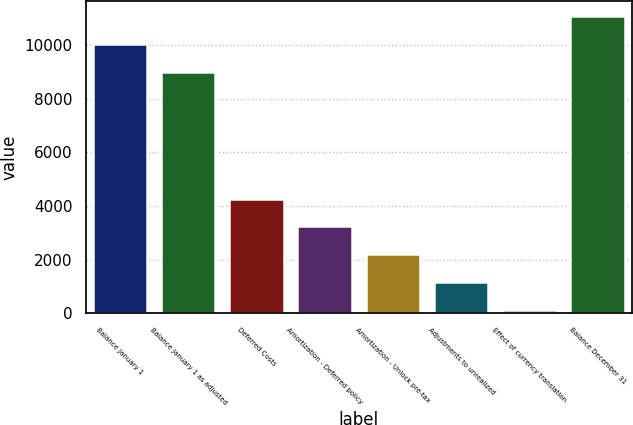<chart> <loc_0><loc_0><loc_500><loc_500><bar_chart><fcel>Balance January 1<fcel>Balance January 1 as adjusted<fcel>Deferred Costs<fcel>Amortization - Deferred policy<fcel>Amortization - Unlock pre-tax<fcel>Adjustments to unrealized<fcel>Effect of currency translation<fcel>Balance December 31<nl><fcel>10031.6<fcel>8992<fcel>4276.4<fcel>3236.8<fcel>2197.2<fcel>1157.6<fcel>118<fcel>11071.2<nl></chart> 